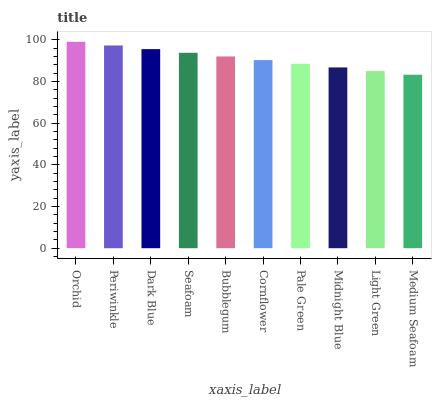Is Medium Seafoam the minimum?
Answer yes or no. Yes. Is Orchid the maximum?
Answer yes or no. Yes. Is Periwinkle the minimum?
Answer yes or no. No. Is Periwinkle the maximum?
Answer yes or no. No. Is Orchid greater than Periwinkle?
Answer yes or no. Yes. Is Periwinkle less than Orchid?
Answer yes or no. Yes. Is Periwinkle greater than Orchid?
Answer yes or no. No. Is Orchid less than Periwinkle?
Answer yes or no. No. Is Bubblegum the high median?
Answer yes or no. Yes. Is Cornflower the low median?
Answer yes or no. Yes. Is Dark Blue the high median?
Answer yes or no. No. Is Midnight Blue the low median?
Answer yes or no. No. 